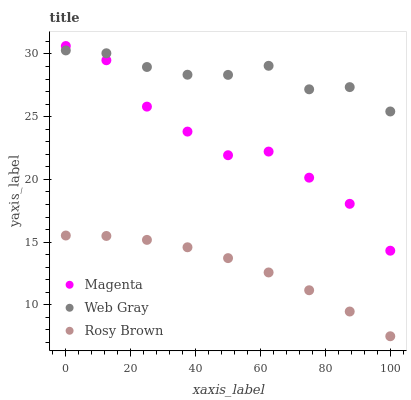Does Rosy Brown have the minimum area under the curve?
Answer yes or no. Yes. Does Web Gray have the maximum area under the curve?
Answer yes or no. Yes. Does Web Gray have the minimum area under the curve?
Answer yes or no. No. Does Rosy Brown have the maximum area under the curve?
Answer yes or no. No. Is Rosy Brown the smoothest?
Answer yes or no. Yes. Is Magenta the roughest?
Answer yes or no. Yes. Is Web Gray the smoothest?
Answer yes or no. No. Is Web Gray the roughest?
Answer yes or no. No. Does Rosy Brown have the lowest value?
Answer yes or no. Yes. Does Web Gray have the lowest value?
Answer yes or no. No. Does Magenta have the highest value?
Answer yes or no. Yes. Does Web Gray have the highest value?
Answer yes or no. No. Is Rosy Brown less than Magenta?
Answer yes or no. Yes. Is Magenta greater than Rosy Brown?
Answer yes or no. Yes. Does Magenta intersect Web Gray?
Answer yes or no. Yes. Is Magenta less than Web Gray?
Answer yes or no. No. Is Magenta greater than Web Gray?
Answer yes or no. No. Does Rosy Brown intersect Magenta?
Answer yes or no. No. 